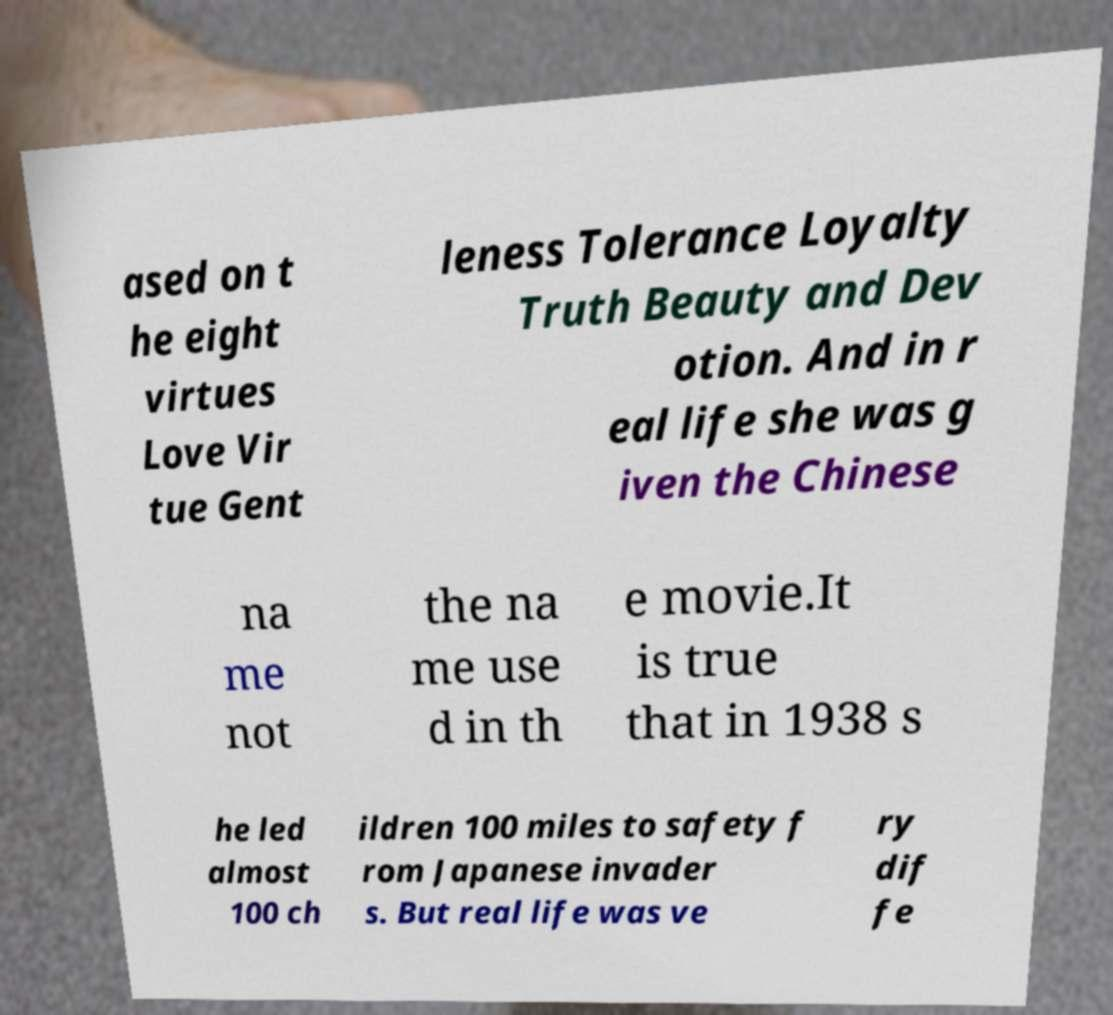Can you read and provide the text displayed in the image?This photo seems to have some interesting text. Can you extract and type it out for me? ased on t he eight virtues Love Vir tue Gent leness Tolerance Loyalty Truth Beauty and Dev otion. And in r eal life she was g iven the Chinese na me not the na me use d in th e movie.It is true that in 1938 s he led almost 100 ch ildren 100 miles to safety f rom Japanese invader s. But real life was ve ry dif fe 